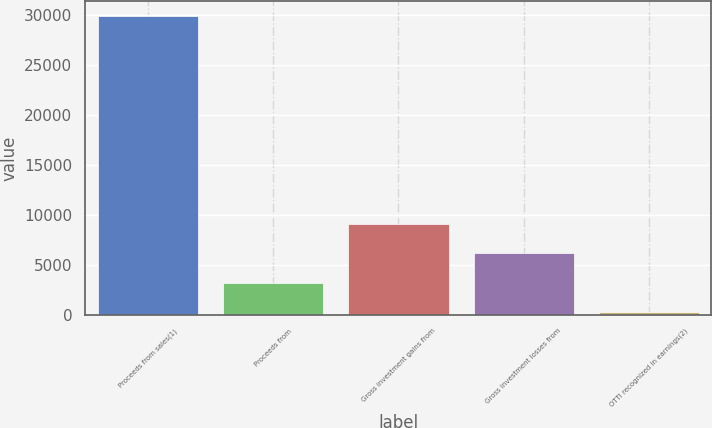Convert chart to OTSL. <chart><loc_0><loc_0><loc_500><loc_500><bar_chart><fcel>Proceeds from sales(1)<fcel>Proceeds from<fcel>Gross investment gains from<fcel>Gross investment losses from<fcel>OTTI recognized in earnings(2)<nl><fcel>29878<fcel>3187.6<fcel>9118.8<fcel>6153.2<fcel>222<nl></chart> 